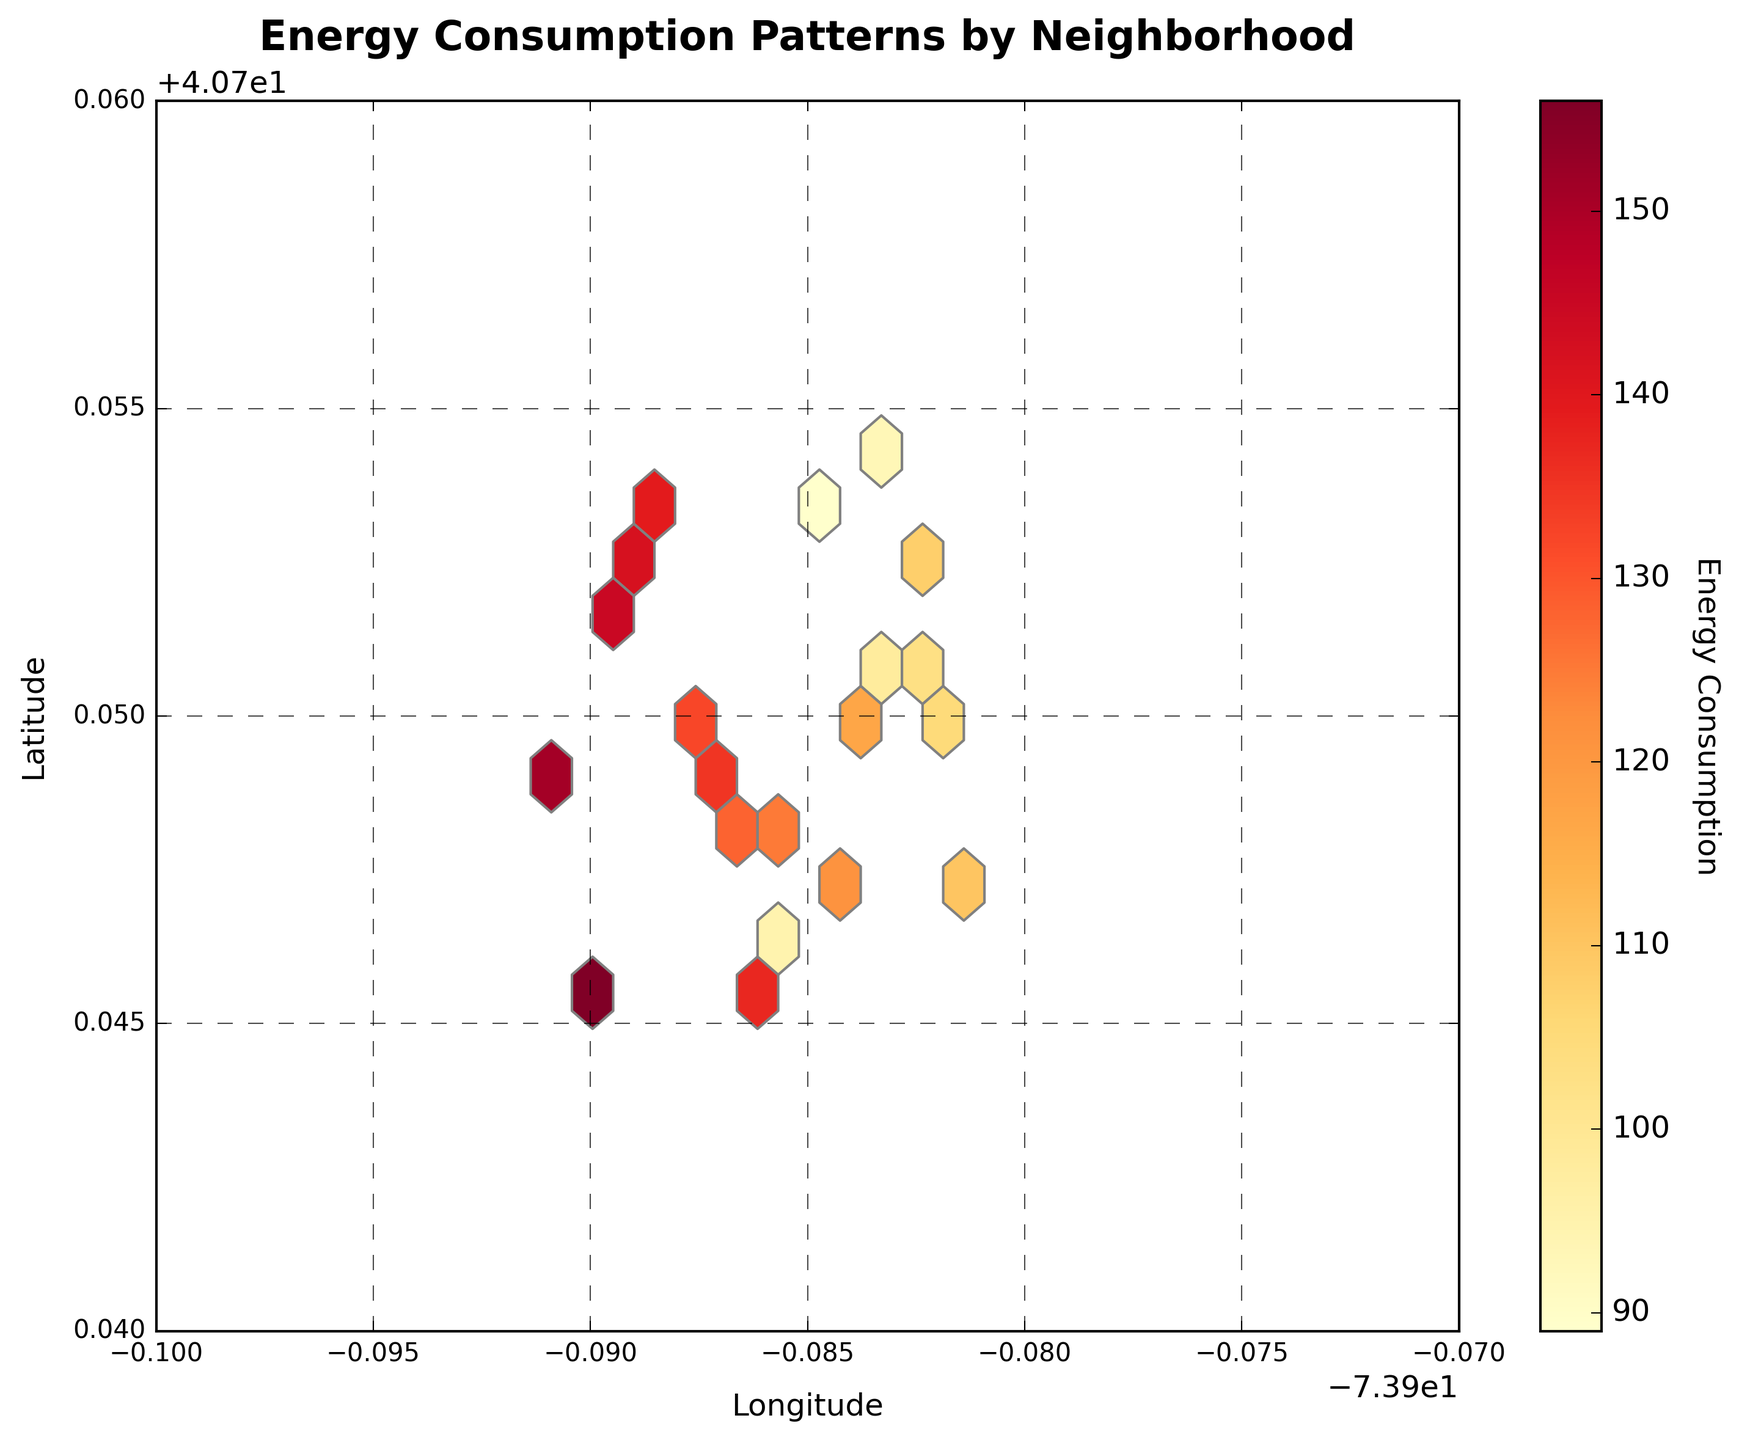What's the title of the plot? The title is found at the top of the figure in large, bold text to summarize the information depicted.
Answer: Energy Consumption Patterns by Neighborhood What does the color gradient in the hexagons represent? The color gradient, indicated by the color bar, represents the energy consumption levels. Darker or more red hexagons signify higher energy consumption.
Answer: Energy consumption levels What's the range of the latitude shown on the y-axis? The range of latitude can be determined from the tick marks along the y-axis. This figure ranges from 40.74 to 40.76.
Answer: 40.74 to 40.76 Which area appears to have the highest energy consumption? The highest energy consumption can be identified by finding the darkest or most red hexagons and checking their position on the plot. Darkest hexagons signify highest energy levels.
Answer: Around latitude 40.7484 and longitude -73.9857 How many grid cells make up the hexbin plot? The size of the grid cells can be deduced by counting the hexagons across the figure both horizontally and vertically. This plot uses a grid size of 10.
Answer: 10 x 10 grid cells What does the color legend on the plot indicate? The color legend or color bar to the right of the plot explains the energy consumption levels, showing which colors correspond to higher or lower levels.
Answer: Energy consumption levels Which neighborhood coordinates appear to have the lowest energy consumption visible in the plot? To find the lowest energy consumption, identify the lightest hexagons, which represent the lowest values, and find their coordinates on the plot.
Answer: Around latitude 40.7538 and longitude -73.9845 What is the energy consumption value associated with the color on the color bar for a medium intensity color? Medium intensity colors fall in the middle of the color bar, so the associated energy consumption will be around the central values represented by these colors.
Answer: Around 125 Does the plot show more high-energy or low-energy neighborhoods? By observing the distribution and the concentration of darker hexagons versus lighter hexagons, one can determine which is more prevalent.
Answer: More high-energy neighborhoods What conclusion can be drawn about the relationship between latitude and energy consumption in this neighborhood? By observing the colors and the hexagons' positions along the latitude, one can infer if there is a pattern or trend in energy consumption relative to latitude.
Answer: Higher consumption appears slightly clustered around certain latitudes 